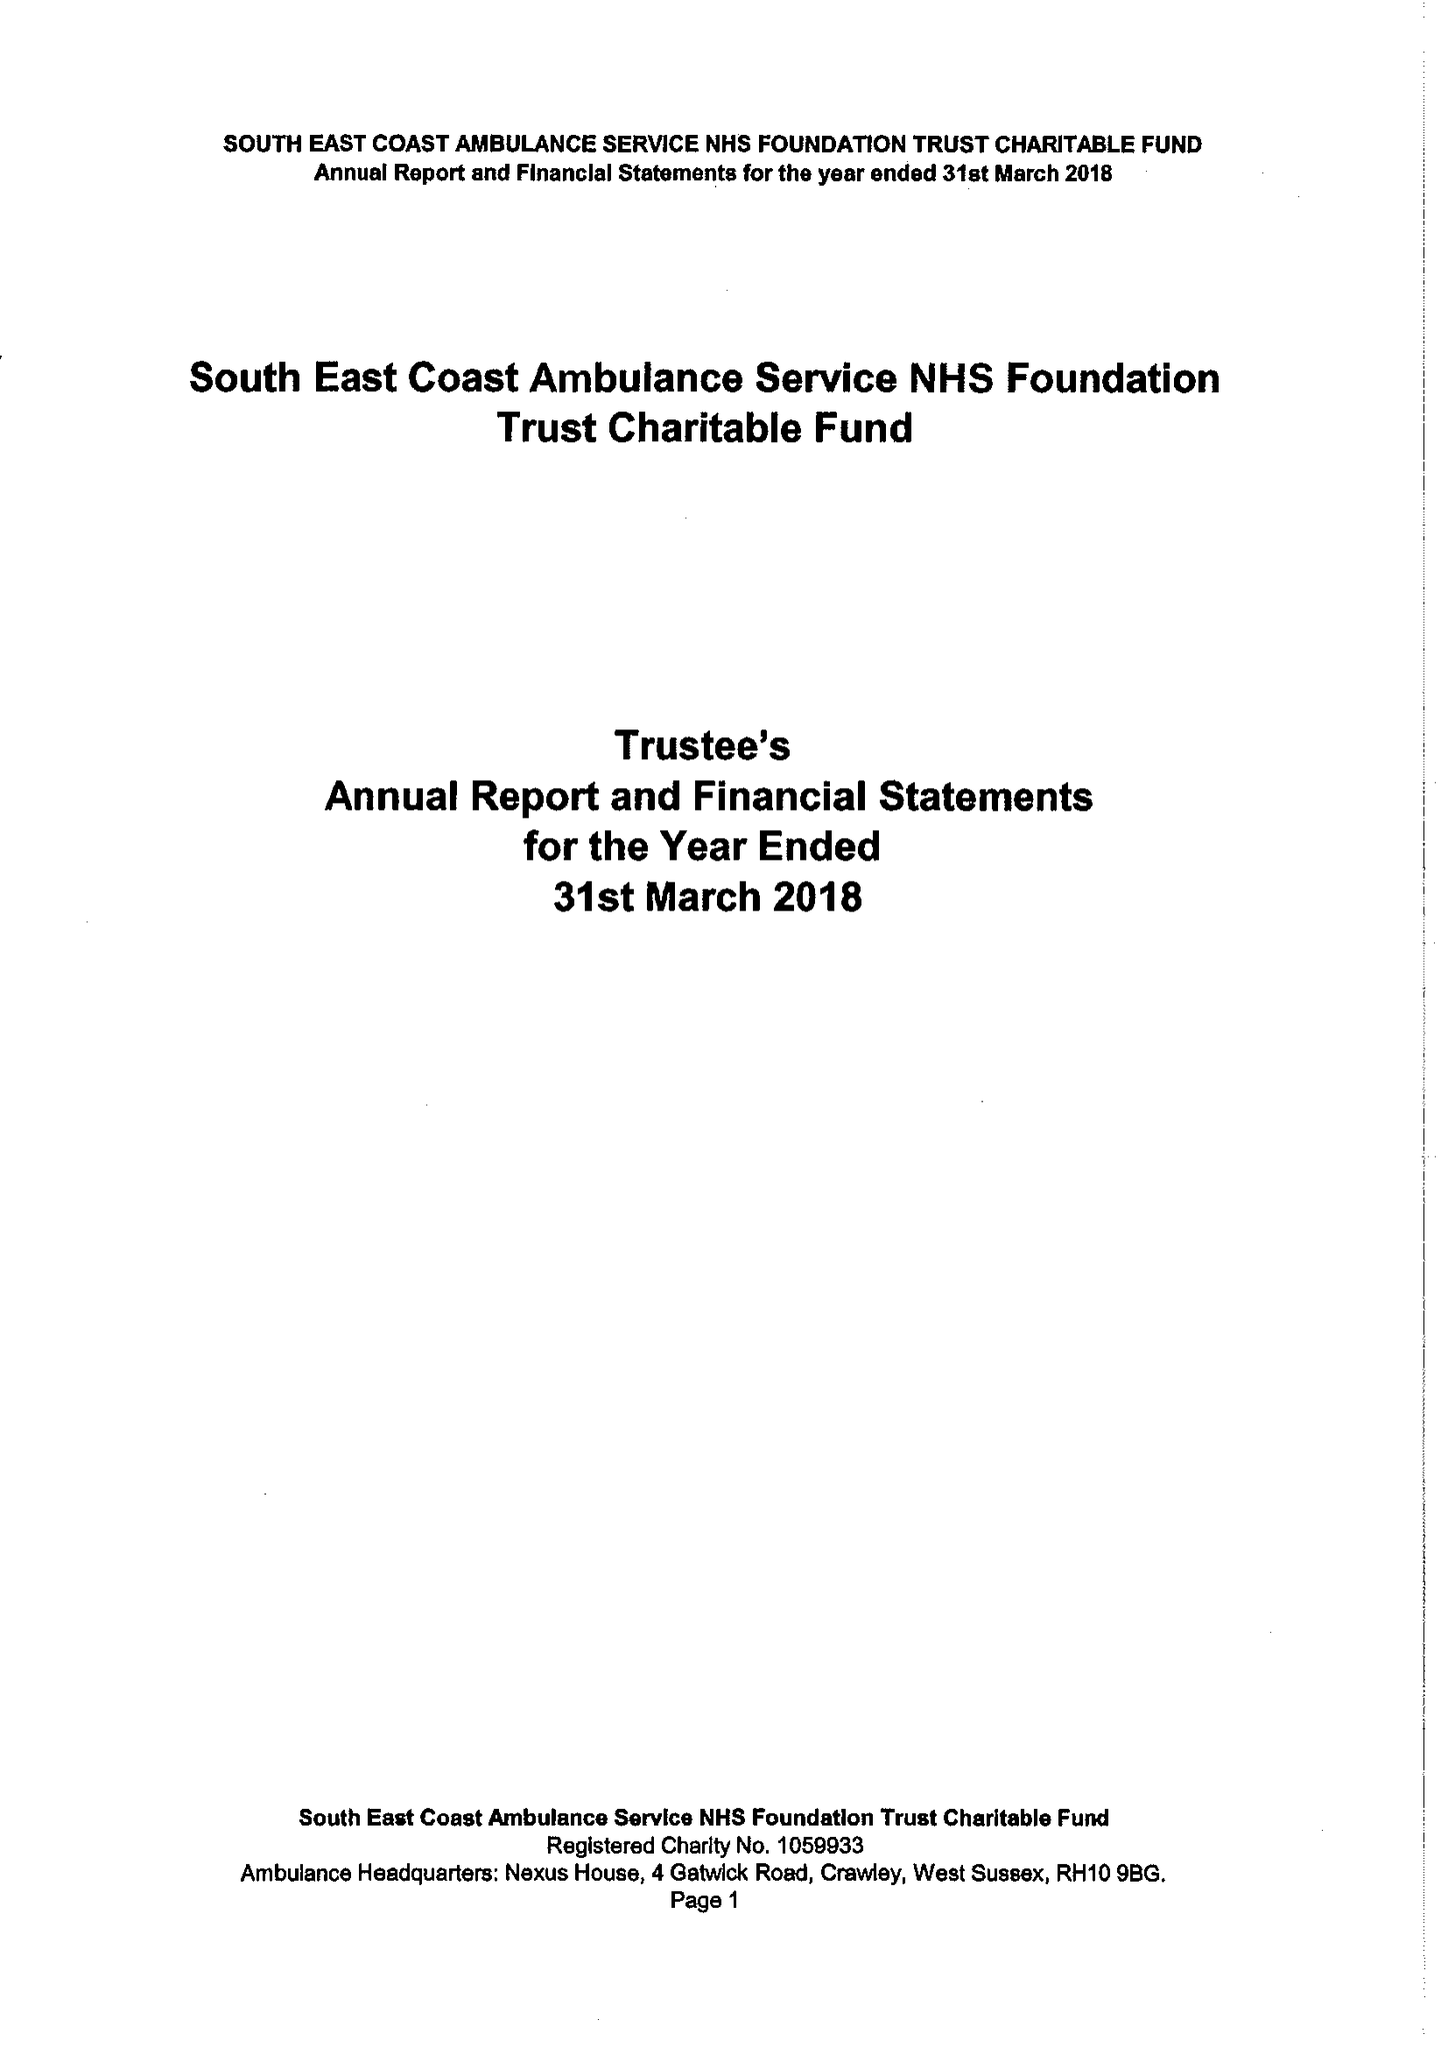What is the value for the address__street_line?
Answer the question using a single word or phrase. 4 GATWICK ROAD 